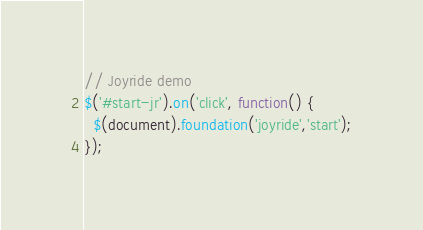Convert code to text. <code><loc_0><loc_0><loc_500><loc_500><_JavaScript_>// Joyride demo
$('#start-jr').on('click', function() {
  $(document).foundation('joyride','start');
});</code> 